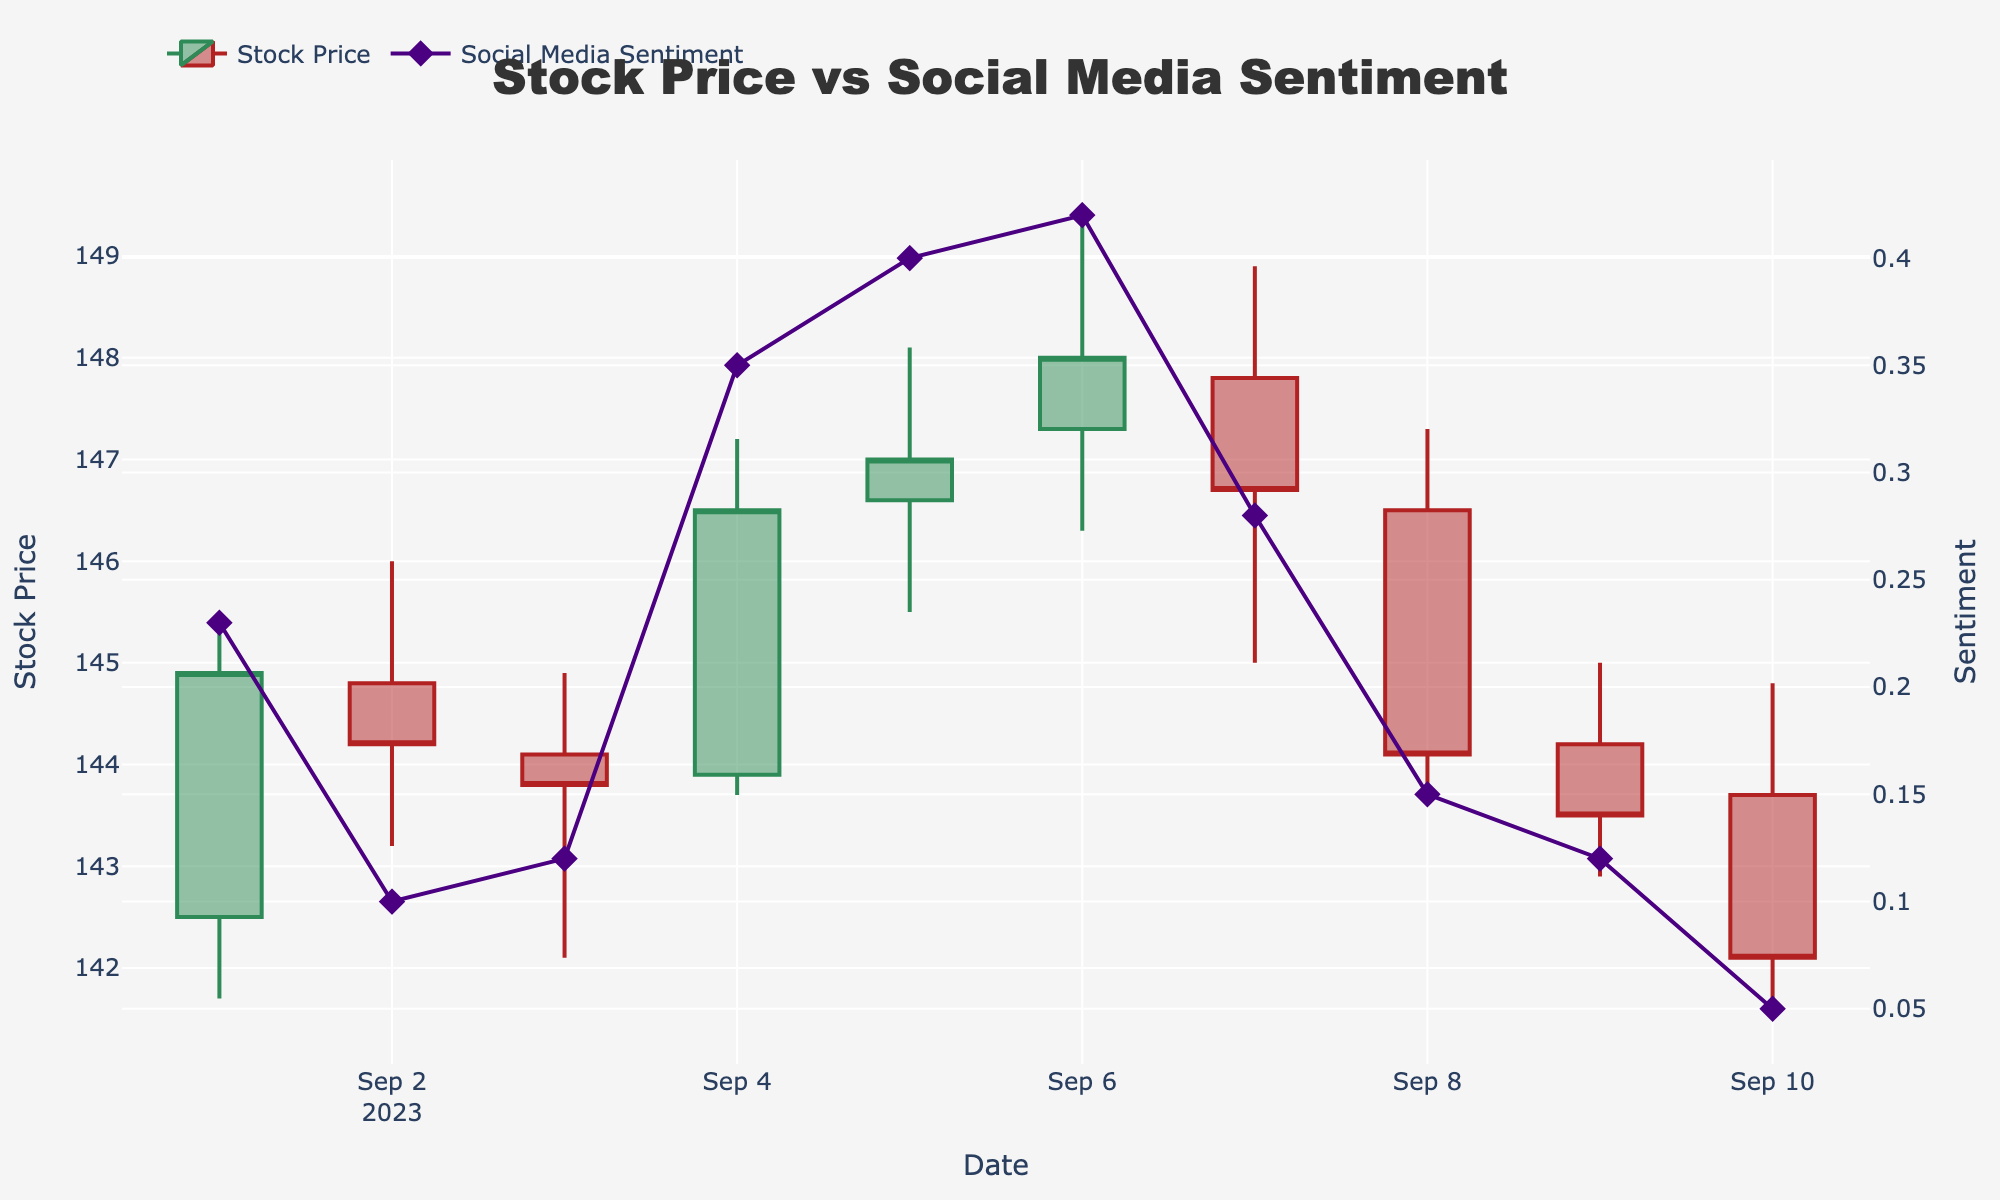What is the title of the plot? The title is located at the top center of the plot and reads "Stock Price vs Social Media Sentiment".
Answer: "Stock Price vs Social Media Sentiment" How many dates are displayed in the figure? The x-axis of the plot, which represents the dates, has 10 distinct points from '2023-09-01' to '2023-09-10'. Counting these dates gives us 10 in total.
Answer: 10 What is the highest stock price recorded? By looking at the highest points in the candlestick plot, we observe that the maximum stock price is on '2023-09-06', at the high value of 149.5.
Answer: 149.5 What date had the highest social media sentiment value? The sentiment trace indicates that the highest social media sentiment value is 0.42, which occurs on '2023-09-06'.
Answer: 2023-09-06 Which date had the lowest closing stock price? The lowest closing stock price can be found by looking at the 'Close' values on the candlestick plot. The lowest value is 142.1, occurring on '2023-09-10'.
Answer: 2023-09-10 Is there a general upward or downward trend in the stock prices from '2023-09-01' to '2023-09-10'? Observing the candlestick plot, the stock prices start around 144.9 on '2023-09-01' and end at 142.1 on '2023-09-10', showing a downward trend overall.
Answer: Downward trend What is the average social media sentiment value over the displayed dates? To calculate the average sentiment, sum all the sentiment values (0.23 + 0.10 + 0.12 + 0.35 + 0.40 + 0.42 + 0.28 + 0.15 + 0.12 + 0.05 = 2.22) and divide by the number of dates (10). The average sentiment value is 2.22/10 = 0.222.
Answer: 0.222 On which dates did the closing stock price exceed 146? By examining the 'Close' values in the candlestick plot, the dates where the closing price exceeded 146 are '2023-09-04', '2023-09-05', '2023-09-06', and '2023-09-07'.
Answer: 2023-09-04, 2023-09-05, 2023-09-06, 2023-09-07 Compare the social media sentiment values on '2023-09-05' and '2023-09-10'. Which is higher? The social media sentiment on '2023-09-05' is 0.40, while on '2023-09-10' it is 0.05. Therefore, the sentiment value on '2023-09-05' is higher.
Answer: 2023-09-05 What is the relationship between the trend in social media sentiment and stock prices on '2023-09-06'? On '2023-09-06', the social media sentiment reaches its peak at 0.42, and the stock prices also show a significant high with a closing value of 148. This suggests a positive correlation.
Answer: Positive correlation 